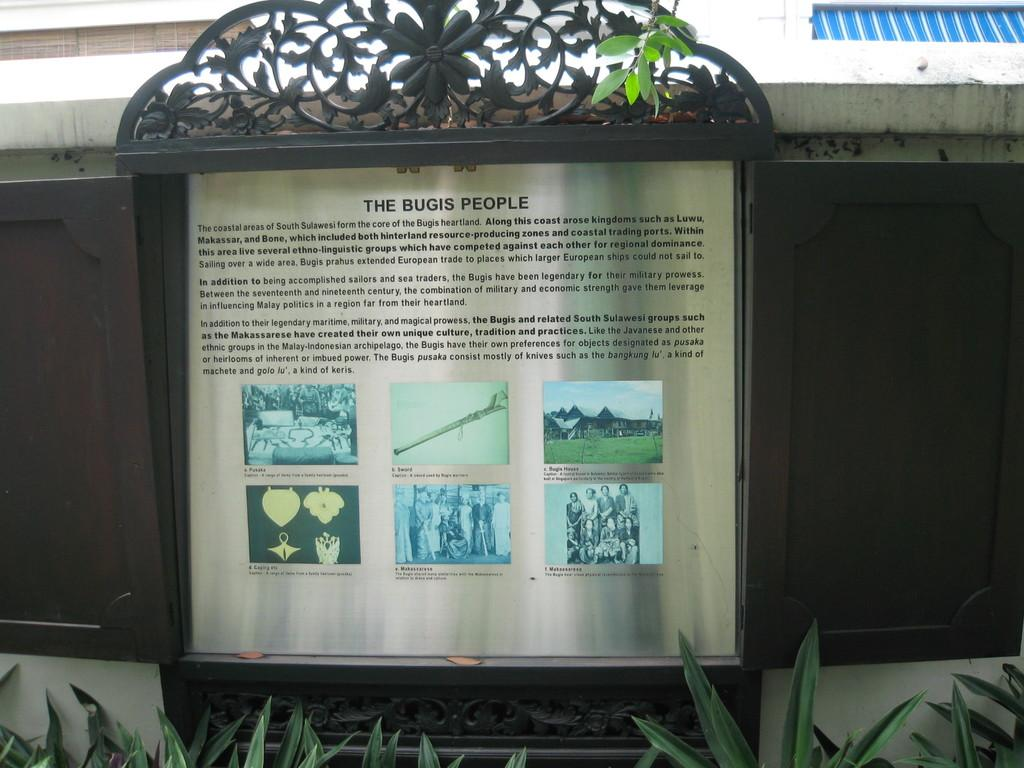What is the main object in the center of the image? There is a board in the center of the image. What type of plants are at the bottom of the image? The plants at the bottom of the image are not specified, but they are present. What can be seen in the background of the image? There is a wall and blinds visible in the background of the image. What date is circled on the calendar in the image? There is no calendar present in the image, so it is not possible to answer that question. 